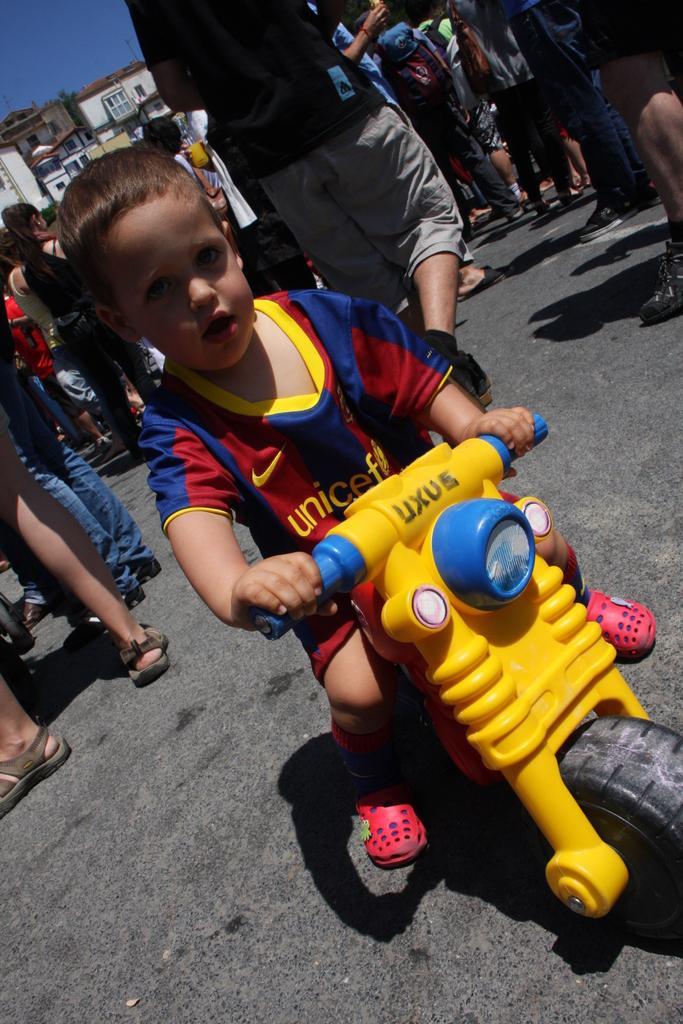Please provide a concise description of this image. This image is clicked outside. There are so many persons in the middle. There is a kid in the middle. There is sky at the top. 